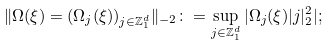<formula> <loc_0><loc_0><loc_500><loc_500>\| \Omega ( \xi ) = ( \Omega _ { j } ( \xi ) ) _ { { j } \in \mathbb { Z } ^ { d } _ { 1 } } \| _ { - 2 } \colon = \sup _ { j \in \mathbb { Z } ^ { d } _ { 1 } } | \Omega _ { j } ( \xi ) | j | _ { 2 } ^ { 2 } | ;</formula> 